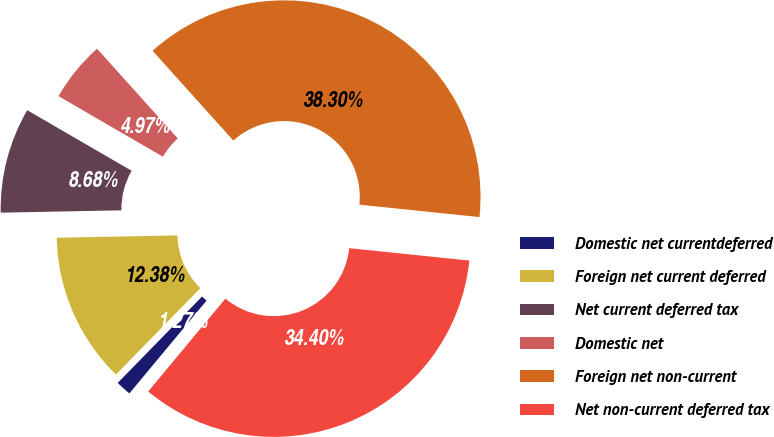Convert chart. <chart><loc_0><loc_0><loc_500><loc_500><pie_chart><fcel>Domestic net currentdeferred<fcel>Foreign net current deferred<fcel>Net current deferred tax<fcel>Domestic net<fcel>Foreign net non-current<fcel>Net non-current deferred tax<nl><fcel>1.27%<fcel>12.38%<fcel>8.68%<fcel>4.97%<fcel>38.3%<fcel>34.4%<nl></chart> 